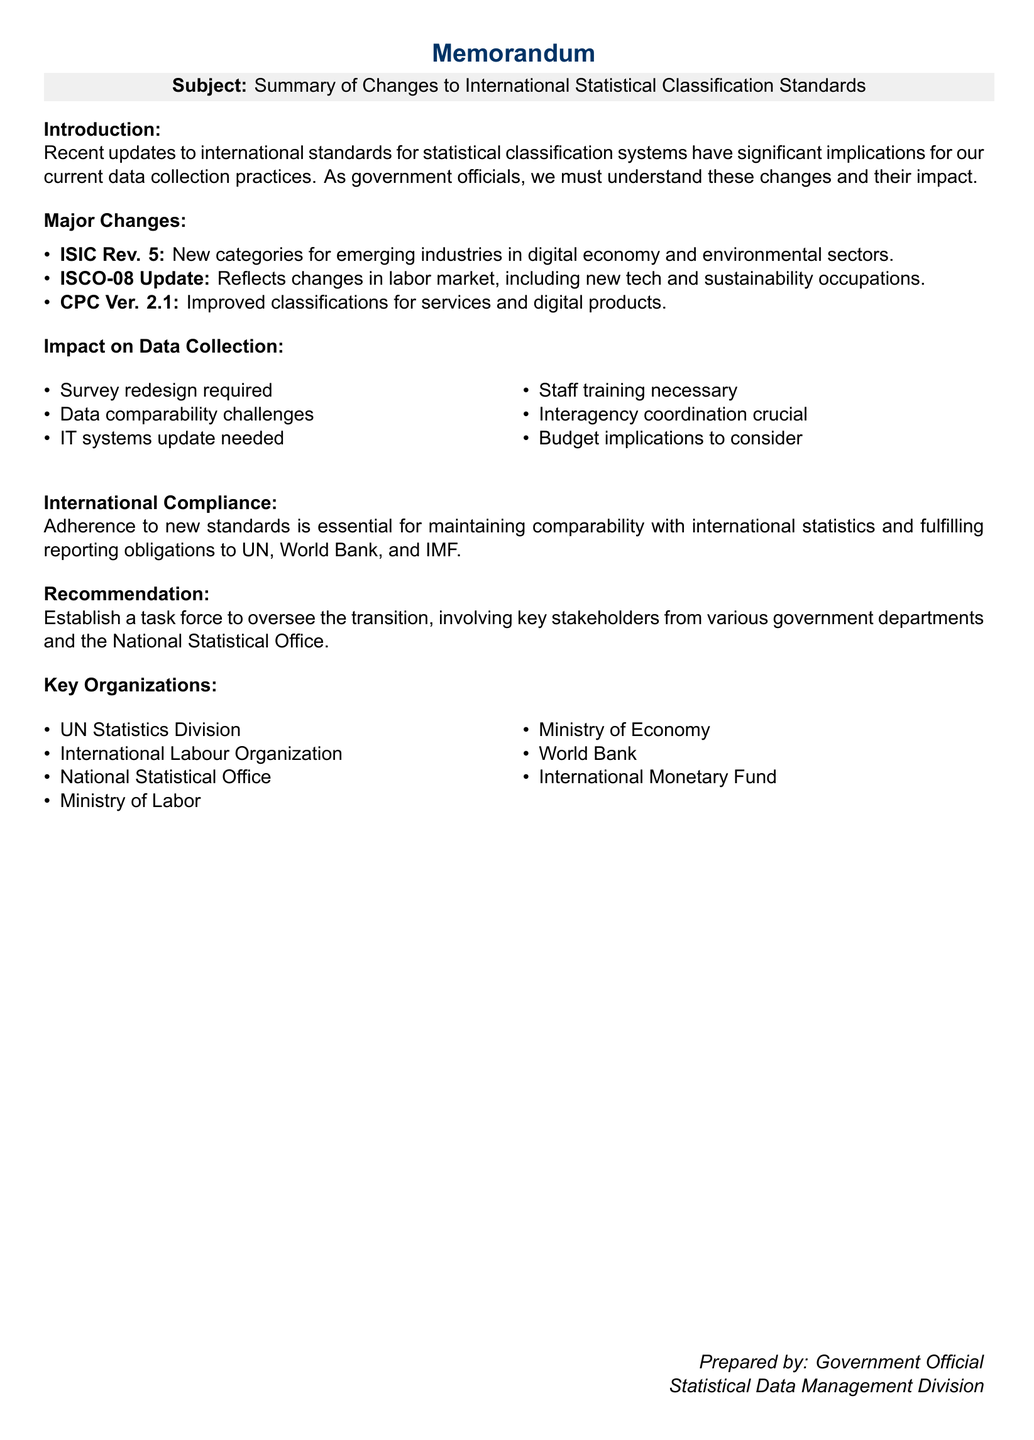What is the subject of the memorandum? The subject of the memorandum is clearly stated in the header section, which reflects the main focus of the document.
Answer: Summary of Changes to International Statistical Classification Standards What organization released the ISIC Rev. 5 update? The organization responsible for this update is mentioned in the document, indicating its authority in statistical classifications.
Answer: United Nations Statistics Division Which classification system has improved classifications for services? The document lists various classification systems and highlights the one that has focused on enhancing service classifications.
Answer: Central Product Classification (CPC) What is one implementation challenge mentioned in the document? The document outlines several challenges that need to be addressed during implementation, highlighting potential obstacles.
Answer: Training What is recommended for overseeing the transition to the new classification standards? The memo provides a specific action item related to the transition process that involves forming a dedicated team.
Answer: Establish a task force Which ministry is crucial for interagency coordination? The document points out specific departments that will play a key role in coordinating efforts regarding the new standards.
Answer: Ministry of Labor What is a potential budget implication mentioned? The document lists implications related to financing changes necessary for implementing new standards and practices.
Answer: Additional funding may be required What is necessary for maintaining international compliance? The document emphasizes the importance of adherence to new standards for meeting global reporting requirements.
Answer: Adherence to new standards 